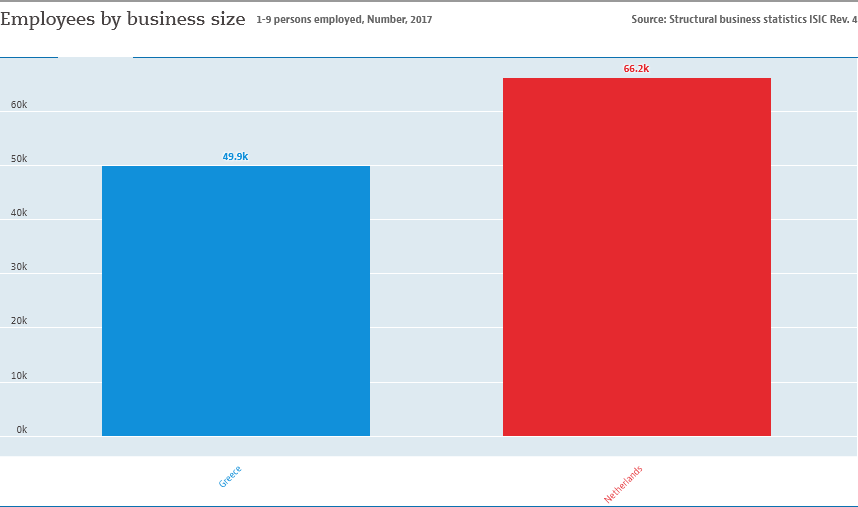Highlight a few significant elements in this photo. The Netherlands is represented by the color red. The average of both countries is 58.05. 